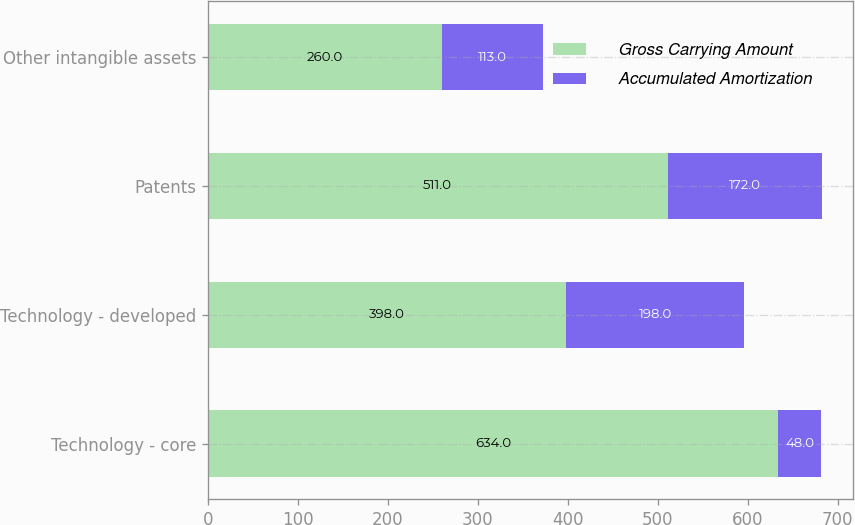Convert chart to OTSL. <chart><loc_0><loc_0><loc_500><loc_500><stacked_bar_chart><ecel><fcel>Technology - core<fcel>Technology - developed<fcel>Patents<fcel>Other intangible assets<nl><fcel>Gross Carrying Amount<fcel>634<fcel>398<fcel>511<fcel>260<nl><fcel>Accumulated Amortization<fcel>48<fcel>198<fcel>172<fcel>113<nl></chart> 